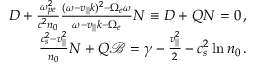Convert formula to latex. <formula><loc_0><loc_0><loc_500><loc_500>\begin{array} { r } { D + \frac { \omega _ { p e } ^ { 2 } } { c ^ { 2 } n _ { 0 } } \frac { ( \omega - v _ { | | } k ) ^ { 2 } - \Omega _ { e } \omega } { \omega - v _ { | | } k - \Omega _ { e } } N \equiv D + Q N = 0 \, , } \\ { \frac { c _ { s } ^ { 2 } - v _ { | | } ^ { 2 } } { n _ { 0 } } N + Q \ m a t h s c r { B } = \gamma - \frac { v _ { | | } ^ { 2 } } { 2 } - c _ { s } ^ { 2 } \ln n _ { 0 } \, . } \end{array}</formula> 